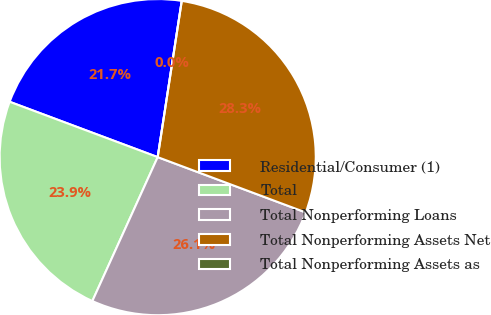Convert chart. <chart><loc_0><loc_0><loc_500><loc_500><pie_chart><fcel>Residential/Consumer (1)<fcel>Total<fcel>Total Nonperforming Loans<fcel>Total Nonperforming Assets Net<fcel>Total Nonperforming Assets as<nl><fcel>21.74%<fcel>23.91%<fcel>26.09%<fcel>28.26%<fcel>0.0%<nl></chart> 